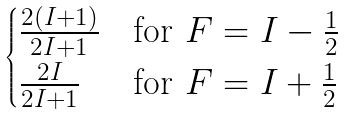Convert formula to latex. <formula><loc_0><loc_0><loc_500><loc_500>\begin{cases} \frac { 2 ( I + 1 ) } { 2 I + 1 } & \text {for $F=I-\frac{1}{2}$} \\ \frac { 2 I } { 2 I + 1 } & \text {for $F=I+\frac{1}{2}$} \end{cases}</formula> 